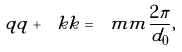Convert formula to latex. <formula><loc_0><loc_0><loc_500><loc_500>\ q q + \ k k = \ m m \frac { 2 \pi } { d _ { 0 } } ,</formula> 